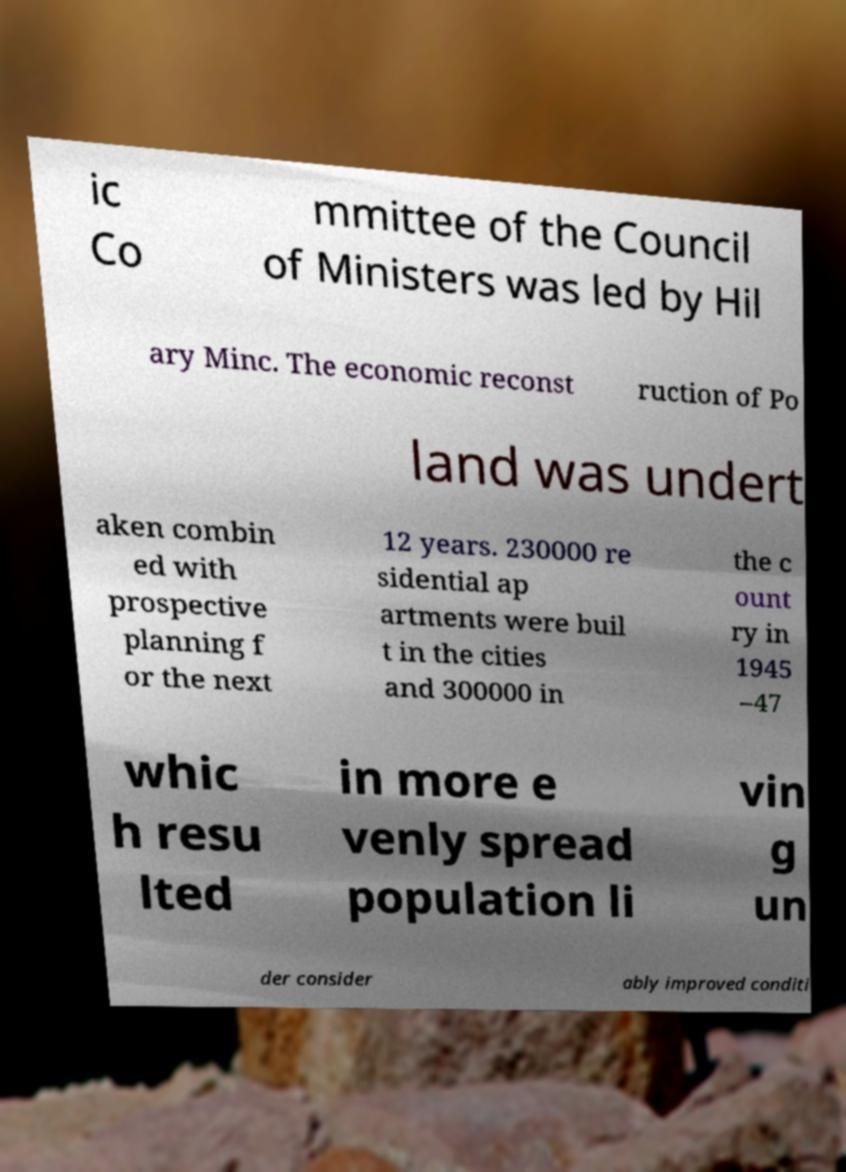Please read and relay the text visible in this image. What does it say? ic Co mmittee of the Council of Ministers was led by Hil ary Minc. The economic reconst ruction of Po land was undert aken combin ed with prospective planning f or the next 12 years. 230000 re sidential ap artments were buil t in the cities and 300000 in the c ount ry in 1945 –47 whic h resu lted in more e venly spread population li vin g un der consider ably improved conditi 